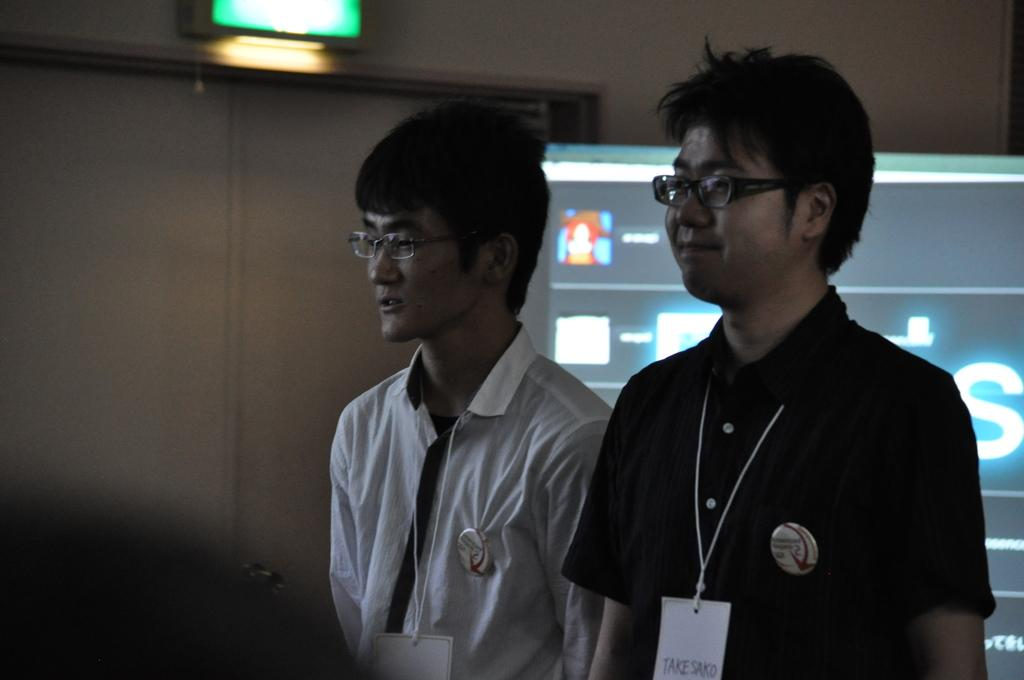How many people are present in the image? There are two people standing in the image. What is the surface on which the people are standing? The people are standing on the floor. What can be seen behind the people? There is a screen and a wall visible behind the people. What type of vegetable is being used as a decoration on the screen in the image? There is no vegetable present on the screen in the image. 